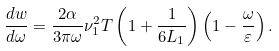Convert formula to latex. <formula><loc_0><loc_0><loc_500><loc_500>\frac { d w } { d \omega } = \frac { 2 \alpha } { 3 \pi \omega } \nu _ { 1 } ^ { 2 } T \left ( 1 + \frac { 1 } { 6 L _ { 1 } } \right ) \left ( 1 - \frac { \omega } { \varepsilon } \right ) .</formula> 